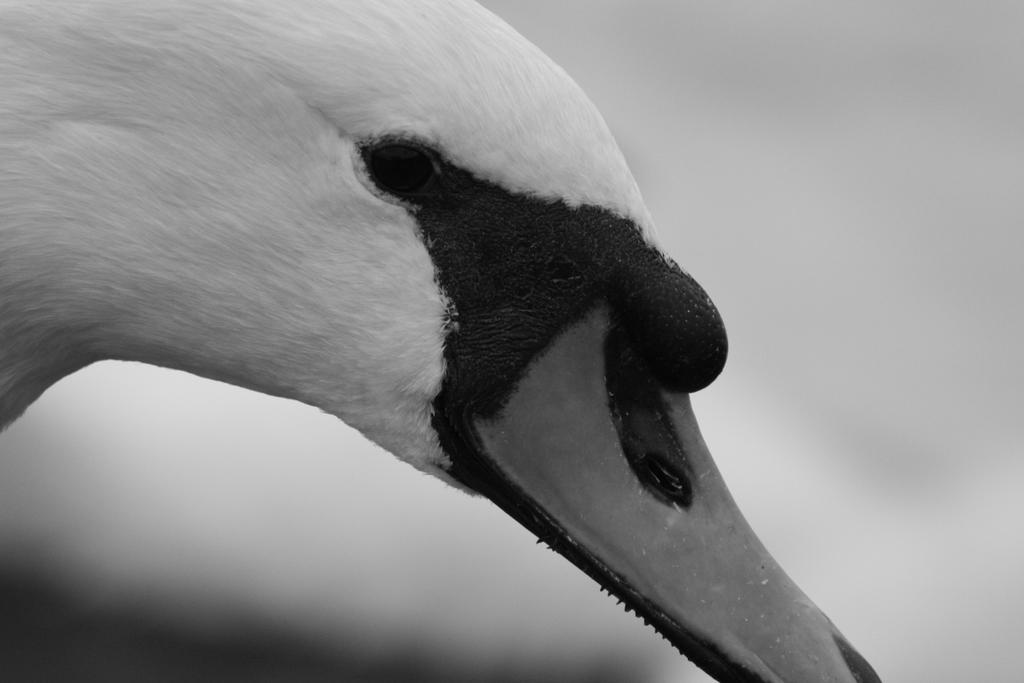What type of face can be seen in the image? There is a duck face in the image. What is the name of the downtown area where the wrench was found in the image? There is no downtown area or wrench present in the image; it only features a duck face. 